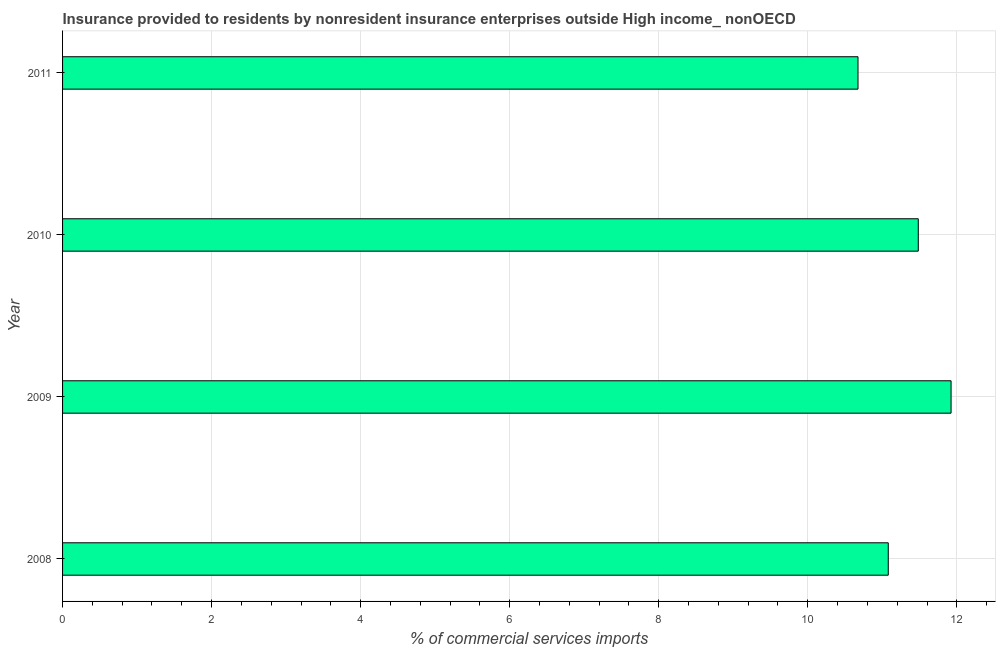Does the graph contain grids?
Offer a terse response. Yes. What is the title of the graph?
Give a very brief answer. Insurance provided to residents by nonresident insurance enterprises outside High income_ nonOECD. What is the label or title of the X-axis?
Keep it short and to the point. % of commercial services imports. What is the label or title of the Y-axis?
Offer a terse response. Year. What is the insurance provided by non-residents in 2011?
Your answer should be very brief. 10.67. Across all years, what is the maximum insurance provided by non-residents?
Offer a very short reply. 11.92. Across all years, what is the minimum insurance provided by non-residents?
Keep it short and to the point. 10.67. In which year was the insurance provided by non-residents maximum?
Provide a succinct answer. 2009. What is the sum of the insurance provided by non-residents?
Your answer should be very brief. 45.16. What is the difference between the insurance provided by non-residents in 2008 and 2011?
Provide a succinct answer. 0.41. What is the average insurance provided by non-residents per year?
Provide a short and direct response. 11.29. What is the median insurance provided by non-residents?
Provide a short and direct response. 11.28. In how many years, is the insurance provided by non-residents greater than 11.6 %?
Give a very brief answer. 1. What is the ratio of the insurance provided by non-residents in 2009 to that in 2010?
Keep it short and to the point. 1.04. Is the insurance provided by non-residents in 2009 less than that in 2011?
Provide a short and direct response. No. What is the difference between the highest and the second highest insurance provided by non-residents?
Keep it short and to the point. 0.44. What is the difference between the highest and the lowest insurance provided by non-residents?
Your answer should be compact. 1.25. What is the difference between two consecutive major ticks on the X-axis?
Provide a short and direct response. 2. Are the values on the major ticks of X-axis written in scientific E-notation?
Make the answer very short. No. What is the % of commercial services imports of 2008?
Ensure brevity in your answer.  11.08. What is the % of commercial services imports in 2009?
Ensure brevity in your answer.  11.92. What is the % of commercial services imports of 2010?
Provide a short and direct response. 11.48. What is the % of commercial services imports of 2011?
Offer a terse response. 10.67. What is the difference between the % of commercial services imports in 2008 and 2009?
Provide a succinct answer. -0.84. What is the difference between the % of commercial services imports in 2008 and 2010?
Offer a terse response. -0.4. What is the difference between the % of commercial services imports in 2008 and 2011?
Your answer should be very brief. 0.41. What is the difference between the % of commercial services imports in 2009 and 2010?
Give a very brief answer. 0.44. What is the difference between the % of commercial services imports in 2009 and 2011?
Provide a succinct answer. 1.25. What is the difference between the % of commercial services imports in 2010 and 2011?
Provide a succinct answer. 0.81. What is the ratio of the % of commercial services imports in 2008 to that in 2009?
Keep it short and to the point. 0.93. What is the ratio of the % of commercial services imports in 2008 to that in 2011?
Keep it short and to the point. 1.04. What is the ratio of the % of commercial services imports in 2009 to that in 2010?
Provide a succinct answer. 1.04. What is the ratio of the % of commercial services imports in 2009 to that in 2011?
Offer a terse response. 1.12. What is the ratio of the % of commercial services imports in 2010 to that in 2011?
Ensure brevity in your answer.  1.08. 